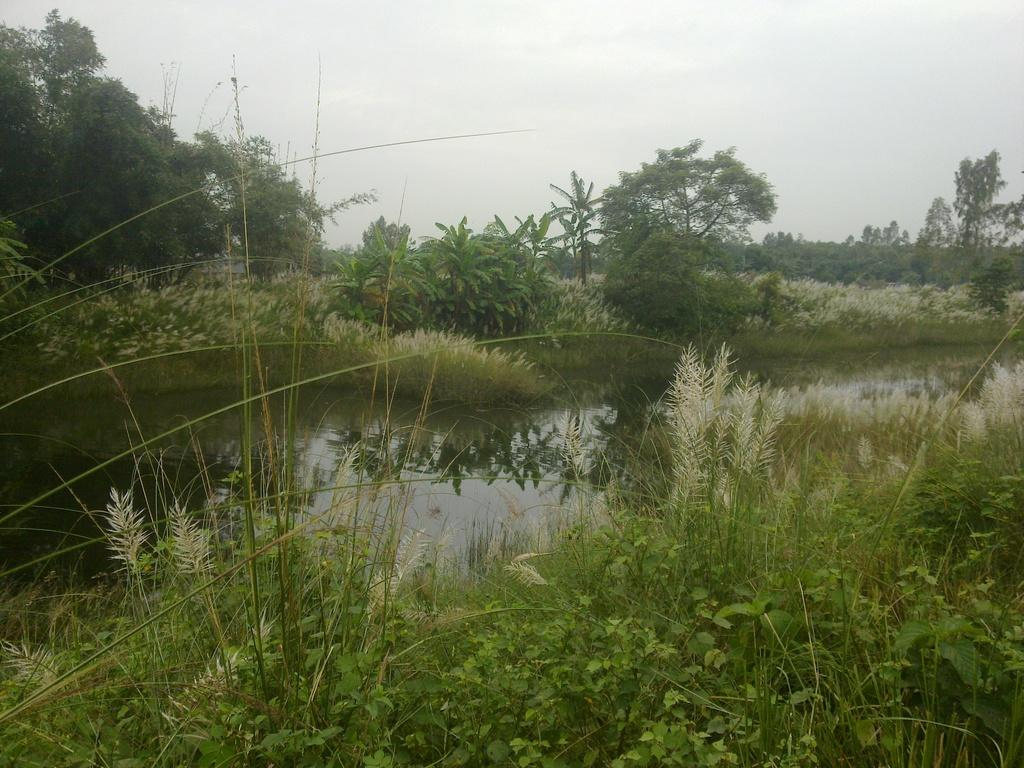What type of natural elements are present in the image? There are plants and trees in the image. What is located in the middle of the image? There is water in the middle of the image. What can be seen in the background of the image? The sky is visible in the background of the image. How would you describe the weather based on the sky's appearance? The sky appears to be clear, suggesting good weather. What type of ornament is hanging from the chin of the tree in the image? There is no ornament hanging from the chin of a tree in the image, as trees do not have chins. 